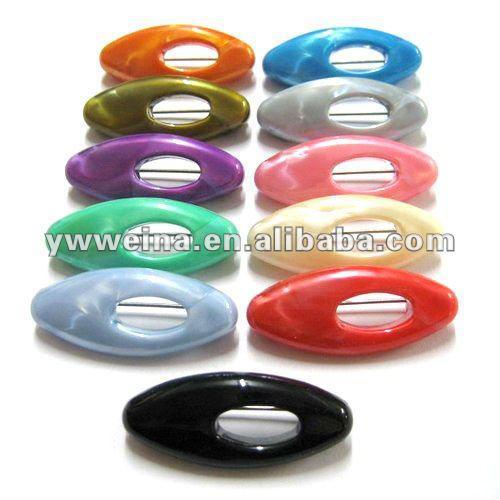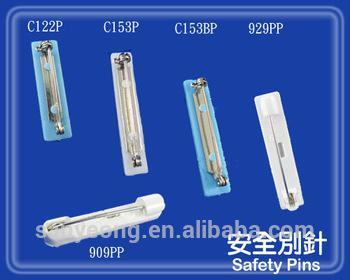The first image is the image on the left, the second image is the image on the right. For the images shown, is this caption "At least one safety pin is purple." true? Answer yes or no. Yes. 